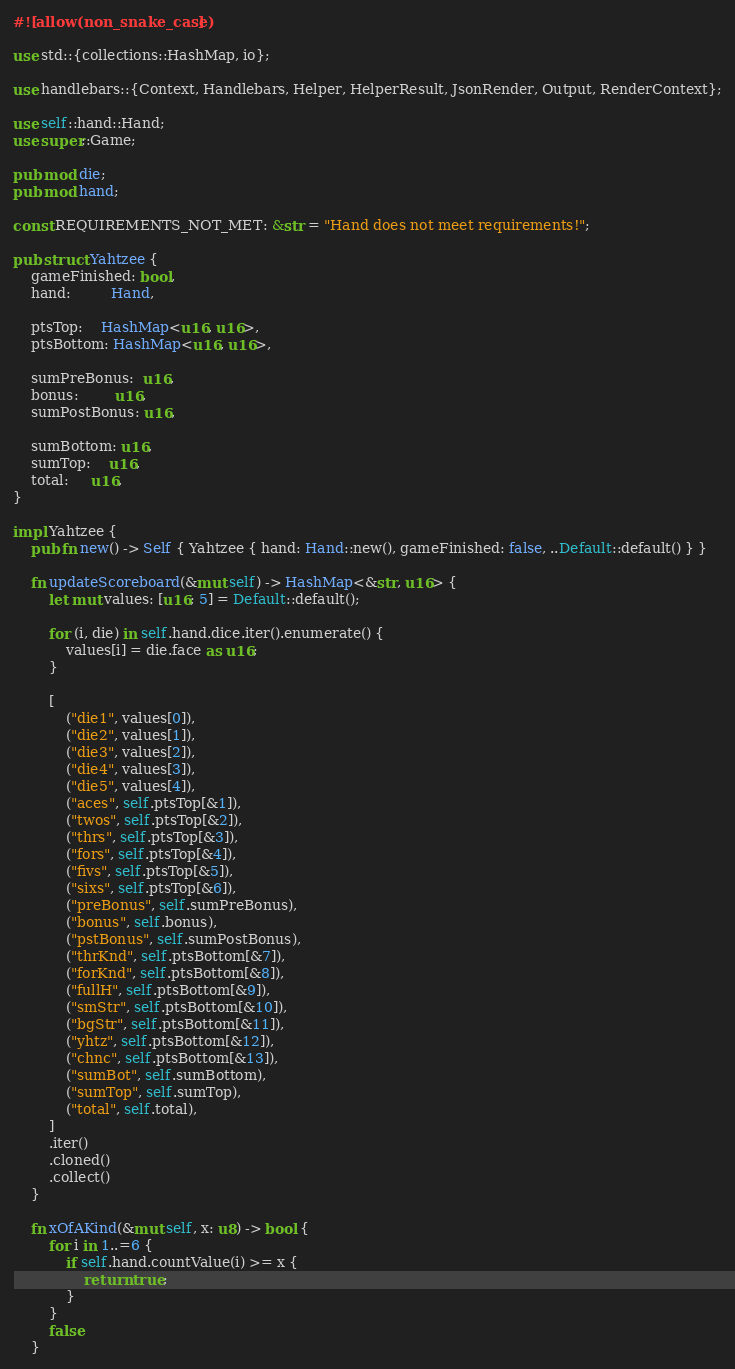<code> <loc_0><loc_0><loc_500><loc_500><_Rust_>#![allow(non_snake_case)]

use std::{collections::HashMap, io};

use handlebars::{Context, Handlebars, Helper, HelperResult, JsonRender, Output, RenderContext};

use self::hand::Hand;
use super::Game;

pub mod die;
pub mod hand;

const REQUIREMENTS_NOT_MET: &str = "Hand does not meet requirements!";

pub struct Yahtzee {
	gameFinished: bool,
	hand:         Hand,

	ptsTop:    HashMap<u16, u16>,
	ptsBottom: HashMap<u16, u16>,

	sumPreBonus:  u16,
	bonus:        u16,
	sumPostBonus: u16,

	sumBottom: u16,
	sumTop:    u16,
	total:     u16,
}

impl Yahtzee {
	pub fn new() -> Self { Yahtzee { hand: Hand::new(), gameFinished: false, ..Default::default() } }

	fn updateScoreboard(&mut self) -> HashMap<&str, u16> {
		let mut values: [u16; 5] = Default::default();

		for (i, die) in self.hand.dice.iter().enumerate() {
			values[i] = die.face as u16;
		}

		[
			("die1", values[0]),
			("die2", values[1]),
			("die3", values[2]),
			("die4", values[3]),
			("die5", values[4]),
			("aces", self.ptsTop[&1]),
			("twos", self.ptsTop[&2]),
			("thrs", self.ptsTop[&3]),
			("fors", self.ptsTop[&4]),
			("fivs", self.ptsTop[&5]),
			("sixs", self.ptsTop[&6]),
			("preBonus", self.sumPreBonus),
			("bonus", self.bonus),
			("pstBonus", self.sumPostBonus),
			("thrKnd", self.ptsBottom[&7]),
			("forKnd", self.ptsBottom[&8]),
			("fullH", self.ptsBottom[&9]),
			("smStr", self.ptsBottom[&10]),
			("bgStr", self.ptsBottom[&11]),
			("yhtz", self.ptsBottom[&12]),
			("chnc", self.ptsBottom[&13]),
			("sumBot", self.sumBottom),
			("sumTop", self.sumTop),
			("total", self.total),
		]
		.iter()
		.cloned()
		.collect()
	}

	fn xOfAKind(&mut self, x: u8) -> bool {
		for i in 1..=6 {
			if self.hand.countValue(i) >= x {
				return true;
			}
		}
		false
	}
</code> 